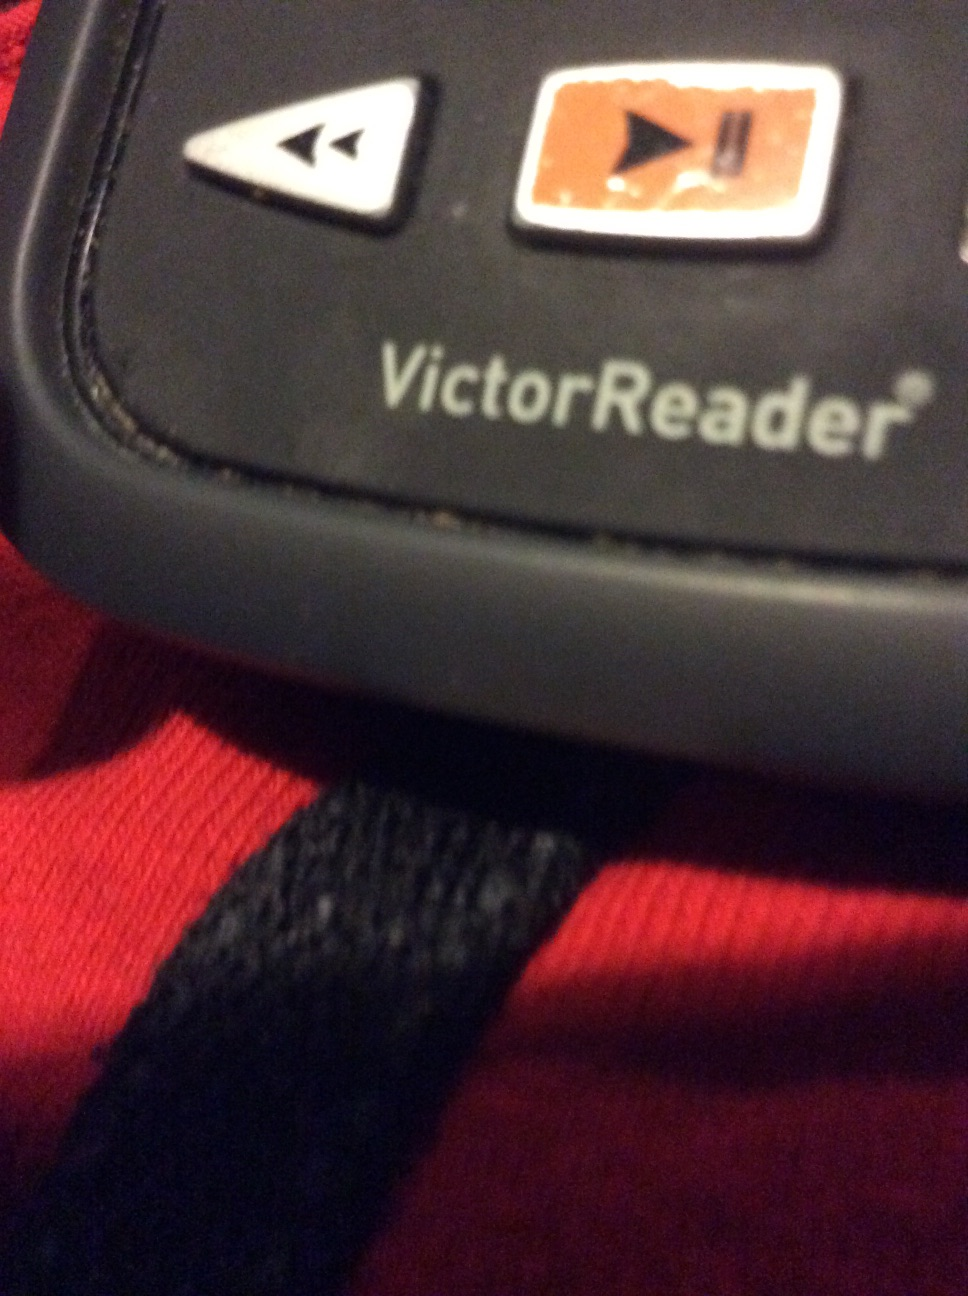Imagine if this device had a voice of a famous character, which character would it be and why? Imagine the VictorReader speaking in the voice of Morgan Freeman. His deep, soothing, and articulate narration would enhance the listening experience, making every book or document feel like an engaging story. 